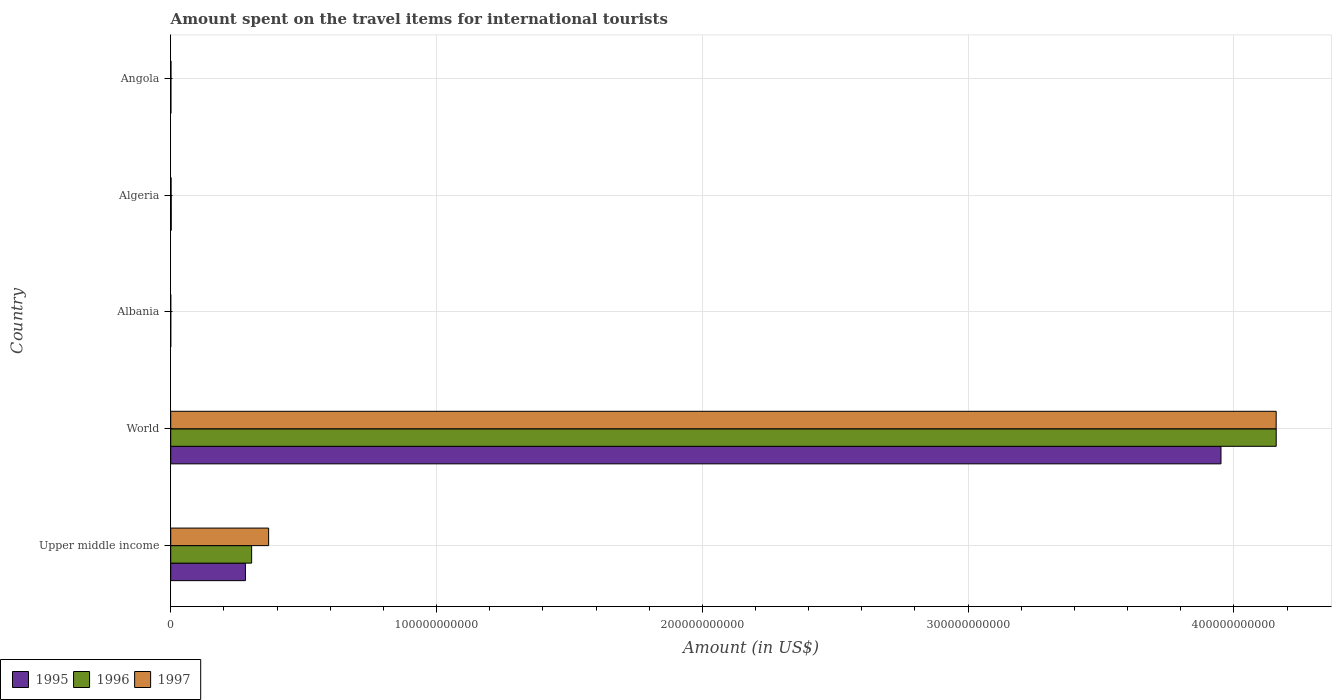Are the number of bars per tick equal to the number of legend labels?
Give a very brief answer. Yes. Are the number of bars on each tick of the Y-axis equal?
Your answer should be compact. Yes. How many bars are there on the 2nd tick from the bottom?
Make the answer very short. 3. What is the label of the 5th group of bars from the top?
Ensure brevity in your answer.  Upper middle income. In how many cases, is the number of bars for a given country not equal to the number of legend labels?
Provide a short and direct response. 0. What is the amount spent on the travel items for international tourists in 1995 in Albania?
Offer a terse response. 7.00e+06. Across all countries, what is the maximum amount spent on the travel items for international tourists in 1995?
Ensure brevity in your answer.  3.95e+11. In which country was the amount spent on the travel items for international tourists in 1995 maximum?
Your answer should be very brief. World. In which country was the amount spent on the travel items for international tourists in 1995 minimum?
Your response must be concise. Albania. What is the total amount spent on the travel items for international tourists in 1995 in the graph?
Make the answer very short. 4.24e+11. What is the difference between the amount spent on the travel items for international tourists in 1995 in Angola and that in Upper middle income?
Offer a terse response. -2.80e+1. What is the difference between the amount spent on the travel items for international tourists in 1996 in Albania and the amount spent on the travel items for international tourists in 1997 in Algeria?
Provide a succinct answer. -1.32e+08. What is the average amount spent on the travel items for international tourists in 1996 per country?
Provide a short and direct response. 8.93e+1. What is the difference between the amount spent on the travel items for international tourists in 1996 and amount spent on the travel items for international tourists in 1997 in Upper middle income?
Give a very brief answer. -6.39e+09. In how many countries, is the amount spent on the travel items for international tourists in 1997 greater than 80000000000 US$?
Ensure brevity in your answer.  1. What is the ratio of the amount spent on the travel items for international tourists in 1995 in Algeria to that in Upper middle income?
Provide a short and direct response. 0.01. Is the difference between the amount spent on the travel items for international tourists in 1996 in Albania and World greater than the difference between the amount spent on the travel items for international tourists in 1997 in Albania and World?
Offer a very short reply. No. What is the difference between the highest and the second highest amount spent on the travel items for international tourists in 1995?
Give a very brief answer. 3.67e+11. What is the difference between the highest and the lowest amount spent on the travel items for international tourists in 1995?
Offer a terse response. 3.95e+11. In how many countries, is the amount spent on the travel items for international tourists in 1997 greater than the average amount spent on the travel items for international tourists in 1997 taken over all countries?
Give a very brief answer. 1. Is the sum of the amount spent on the travel items for international tourists in 1996 in Albania and Algeria greater than the maximum amount spent on the travel items for international tourists in 1997 across all countries?
Your response must be concise. No. Is it the case that in every country, the sum of the amount spent on the travel items for international tourists in 1997 and amount spent on the travel items for international tourists in 1995 is greater than the amount spent on the travel items for international tourists in 1996?
Provide a short and direct response. No. Are all the bars in the graph horizontal?
Offer a terse response. Yes. What is the difference between two consecutive major ticks on the X-axis?
Provide a succinct answer. 1.00e+11. Does the graph contain any zero values?
Your response must be concise. No. How are the legend labels stacked?
Make the answer very short. Horizontal. What is the title of the graph?
Your response must be concise. Amount spent on the travel items for international tourists. What is the label or title of the X-axis?
Offer a terse response. Amount (in US$). What is the Amount (in US$) of 1995 in Upper middle income?
Your answer should be very brief. 2.81e+1. What is the Amount (in US$) of 1996 in Upper middle income?
Provide a succinct answer. 3.04e+1. What is the Amount (in US$) of 1997 in Upper middle income?
Your answer should be very brief. 3.68e+1. What is the Amount (in US$) in 1995 in World?
Give a very brief answer. 3.95e+11. What is the Amount (in US$) in 1996 in World?
Ensure brevity in your answer.  4.16e+11. What is the Amount (in US$) of 1997 in World?
Provide a succinct answer. 4.16e+11. What is the Amount (in US$) in 1995 in Albania?
Offer a very short reply. 7.00e+06. What is the Amount (in US$) of 1995 in Algeria?
Keep it short and to the point. 1.86e+08. What is the Amount (in US$) of 1996 in Algeria?
Your response must be concise. 1.88e+08. What is the Amount (in US$) of 1997 in Algeria?
Offer a terse response. 1.44e+08. What is the Amount (in US$) of 1995 in Angola?
Provide a succinct answer. 7.50e+07. What is the Amount (in US$) in 1996 in Angola?
Ensure brevity in your answer.  7.30e+07. What is the Amount (in US$) in 1997 in Angola?
Offer a terse response. 9.80e+07. Across all countries, what is the maximum Amount (in US$) in 1995?
Offer a terse response. 3.95e+11. Across all countries, what is the maximum Amount (in US$) in 1996?
Provide a succinct answer. 4.16e+11. Across all countries, what is the maximum Amount (in US$) of 1997?
Your answer should be compact. 4.16e+11. Across all countries, what is the minimum Amount (in US$) in 1995?
Keep it short and to the point. 7.00e+06. What is the total Amount (in US$) of 1995 in the graph?
Offer a terse response. 4.24e+11. What is the total Amount (in US$) in 1996 in the graph?
Your answer should be very brief. 4.47e+11. What is the total Amount (in US$) in 1997 in the graph?
Offer a terse response. 4.53e+11. What is the difference between the Amount (in US$) in 1995 in Upper middle income and that in World?
Your answer should be compact. -3.67e+11. What is the difference between the Amount (in US$) in 1996 in Upper middle income and that in World?
Give a very brief answer. -3.85e+11. What is the difference between the Amount (in US$) in 1997 in Upper middle income and that in World?
Provide a succinct answer. -3.79e+11. What is the difference between the Amount (in US$) in 1995 in Upper middle income and that in Albania?
Your answer should be very brief. 2.81e+1. What is the difference between the Amount (in US$) in 1996 in Upper middle income and that in Albania?
Give a very brief answer. 3.04e+1. What is the difference between the Amount (in US$) of 1997 in Upper middle income and that in Albania?
Your response must be concise. 3.68e+1. What is the difference between the Amount (in US$) in 1995 in Upper middle income and that in Algeria?
Provide a succinct answer. 2.79e+1. What is the difference between the Amount (in US$) of 1996 in Upper middle income and that in Algeria?
Provide a short and direct response. 3.03e+1. What is the difference between the Amount (in US$) in 1997 in Upper middle income and that in Algeria?
Give a very brief answer. 3.67e+1. What is the difference between the Amount (in US$) of 1995 in Upper middle income and that in Angola?
Your answer should be compact. 2.80e+1. What is the difference between the Amount (in US$) of 1996 in Upper middle income and that in Angola?
Your answer should be very brief. 3.04e+1. What is the difference between the Amount (in US$) of 1997 in Upper middle income and that in Angola?
Ensure brevity in your answer.  3.67e+1. What is the difference between the Amount (in US$) of 1995 in World and that in Albania?
Your response must be concise. 3.95e+11. What is the difference between the Amount (in US$) in 1996 in World and that in Albania?
Offer a very short reply. 4.16e+11. What is the difference between the Amount (in US$) of 1997 in World and that in Albania?
Provide a short and direct response. 4.16e+11. What is the difference between the Amount (in US$) in 1995 in World and that in Algeria?
Offer a terse response. 3.95e+11. What is the difference between the Amount (in US$) in 1996 in World and that in Algeria?
Your answer should be compact. 4.16e+11. What is the difference between the Amount (in US$) in 1997 in World and that in Algeria?
Give a very brief answer. 4.16e+11. What is the difference between the Amount (in US$) in 1995 in World and that in Angola?
Your answer should be very brief. 3.95e+11. What is the difference between the Amount (in US$) of 1996 in World and that in Angola?
Give a very brief answer. 4.16e+11. What is the difference between the Amount (in US$) of 1997 in World and that in Angola?
Your answer should be very brief. 4.16e+11. What is the difference between the Amount (in US$) of 1995 in Albania and that in Algeria?
Give a very brief answer. -1.79e+08. What is the difference between the Amount (in US$) in 1996 in Albania and that in Algeria?
Ensure brevity in your answer.  -1.76e+08. What is the difference between the Amount (in US$) of 1997 in Albania and that in Algeria?
Your answer should be compact. -1.39e+08. What is the difference between the Amount (in US$) in 1995 in Albania and that in Angola?
Offer a terse response. -6.80e+07. What is the difference between the Amount (in US$) in 1996 in Albania and that in Angola?
Provide a succinct answer. -6.10e+07. What is the difference between the Amount (in US$) of 1997 in Albania and that in Angola?
Your answer should be compact. -9.30e+07. What is the difference between the Amount (in US$) of 1995 in Algeria and that in Angola?
Your answer should be compact. 1.11e+08. What is the difference between the Amount (in US$) in 1996 in Algeria and that in Angola?
Your answer should be very brief. 1.15e+08. What is the difference between the Amount (in US$) of 1997 in Algeria and that in Angola?
Offer a terse response. 4.60e+07. What is the difference between the Amount (in US$) of 1995 in Upper middle income and the Amount (in US$) of 1996 in World?
Provide a succinct answer. -3.88e+11. What is the difference between the Amount (in US$) in 1995 in Upper middle income and the Amount (in US$) in 1997 in World?
Give a very brief answer. -3.88e+11. What is the difference between the Amount (in US$) in 1996 in Upper middle income and the Amount (in US$) in 1997 in World?
Your response must be concise. -3.85e+11. What is the difference between the Amount (in US$) of 1995 in Upper middle income and the Amount (in US$) of 1996 in Albania?
Your answer should be compact. 2.81e+1. What is the difference between the Amount (in US$) in 1995 in Upper middle income and the Amount (in US$) in 1997 in Albania?
Offer a very short reply. 2.81e+1. What is the difference between the Amount (in US$) in 1996 in Upper middle income and the Amount (in US$) in 1997 in Albania?
Offer a very short reply. 3.04e+1. What is the difference between the Amount (in US$) in 1995 in Upper middle income and the Amount (in US$) in 1996 in Algeria?
Make the answer very short. 2.79e+1. What is the difference between the Amount (in US$) of 1995 in Upper middle income and the Amount (in US$) of 1997 in Algeria?
Offer a very short reply. 2.80e+1. What is the difference between the Amount (in US$) of 1996 in Upper middle income and the Amount (in US$) of 1997 in Algeria?
Offer a terse response. 3.03e+1. What is the difference between the Amount (in US$) in 1995 in Upper middle income and the Amount (in US$) in 1996 in Angola?
Make the answer very short. 2.80e+1. What is the difference between the Amount (in US$) in 1995 in Upper middle income and the Amount (in US$) in 1997 in Angola?
Offer a terse response. 2.80e+1. What is the difference between the Amount (in US$) in 1996 in Upper middle income and the Amount (in US$) in 1997 in Angola?
Your response must be concise. 3.03e+1. What is the difference between the Amount (in US$) of 1995 in World and the Amount (in US$) of 1996 in Albania?
Offer a terse response. 3.95e+11. What is the difference between the Amount (in US$) in 1995 in World and the Amount (in US$) in 1997 in Albania?
Your response must be concise. 3.95e+11. What is the difference between the Amount (in US$) in 1996 in World and the Amount (in US$) in 1997 in Albania?
Keep it short and to the point. 4.16e+11. What is the difference between the Amount (in US$) in 1995 in World and the Amount (in US$) in 1996 in Algeria?
Keep it short and to the point. 3.95e+11. What is the difference between the Amount (in US$) of 1995 in World and the Amount (in US$) of 1997 in Algeria?
Your answer should be compact. 3.95e+11. What is the difference between the Amount (in US$) of 1996 in World and the Amount (in US$) of 1997 in Algeria?
Provide a short and direct response. 4.16e+11. What is the difference between the Amount (in US$) of 1995 in World and the Amount (in US$) of 1996 in Angola?
Offer a terse response. 3.95e+11. What is the difference between the Amount (in US$) of 1995 in World and the Amount (in US$) of 1997 in Angola?
Your answer should be very brief. 3.95e+11. What is the difference between the Amount (in US$) in 1996 in World and the Amount (in US$) in 1997 in Angola?
Keep it short and to the point. 4.16e+11. What is the difference between the Amount (in US$) of 1995 in Albania and the Amount (in US$) of 1996 in Algeria?
Give a very brief answer. -1.81e+08. What is the difference between the Amount (in US$) of 1995 in Albania and the Amount (in US$) of 1997 in Algeria?
Your response must be concise. -1.37e+08. What is the difference between the Amount (in US$) in 1996 in Albania and the Amount (in US$) in 1997 in Algeria?
Ensure brevity in your answer.  -1.32e+08. What is the difference between the Amount (in US$) in 1995 in Albania and the Amount (in US$) in 1996 in Angola?
Ensure brevity in your answer.  -6.60e+07. What is the difference between the Amount (in US$) of 1995 in Albania and the Amount (in US$) of 1997 in Angola?
Provide a short and direct response. -9.10e+07. What is the difference between the Amount (in US$) in 1996 in Albania and the Amount (in US$) in 1997 in Angola?
Provide a succinct answer. -8.60e+07. What is the difference between the Amount (in US$) in 1995 in Algeria and the Amount (in US$) in 1996 in Angola?
Keep it short and to the point. 1.13e+08. What is the difference between the Amount (in US$) in 1995 in Algeria and the Amount (in US$) in 1997 in Angola?
Your response must be concise. 8.80e+07. What is the difference between the Amount (in US$) of 1996 in Algeria and the Amount (in US$) of 1997 in Angola?
Your answer should be compact. 9.00e+07. What is the average Amount (in US$) in 1995 per country?
Offer a very short reply. 8.47e+1. What is the average Amount (in US$) of 1996 per country?
Your response must be concise. 8.93e+1. What is the average Amount (in US$) of 1997 per country?
Offer a very short reply. 9.06e+1. What is the difference between the Amount (in US$) of 1995 and Amount (in US$) of 1996 in Upper middle income?
Your response must be concise. -2.34e+09. What is the difference between the Amount (in US$) of 1995 and Amount (in US$) of 1997 in Upper middle income?
Your response must be concise. -8.72e+09. What is the difference between the Amount (in US$) in 1996 and Amount (in US$) in 1997 in Upper middle income?
Provide a short and direct response. -6.39e+09. What is the difference between the Amount (in US$) of 1995 and Amount (in US$) of 1996 in World?
Your answer should be very brief. -2.08e+1. What is the difference between the Amount (in US$) of 1995 and Amount (in US$) of 1997 in World?
Make the answer very short. -2.08e+1. What is the difference between the Amount (in US$) of 1996 and Amount (in US$) of 1997 in World?
Offer a terse response. 1.91e+07. What is the difference between the Amount (in US$) in 1995 and Amount (in US$) in 1996 in Albania?
Your answer should be compact. -5.00e+06. What is the difference between the Amount (in US$) in 1995 and Amount (in US$) in 1997 in Algeria?
Your answer should be very brief. 4.20e+07. What is the difference between the Amount (in US$) in 1996 and Amount (in US$) in 1997 in Algeria?
Your answer should be compact. 4.40e+07. What is the difference between the Amount (in US$) of 1995 and Amount (in US$) of 1997 in Angola?
Keep it short and to the point. -2.30e+07. What is the difference between the Amount (in US$) of 1996 and Amount (in US$) of 1997 in Angola?
Ensure brevity in your answer.  -2.50e+07. What is the ratio of the Amount (in US$) in 1995 in Upper middle income to that in World?
Give a very brief answer. 0.07. What is the ratio of the Amount (in US$) in 1996 in Upper middle income to that in World?
Provide a short and direct response. 0.07. What is the ratio of the Amount (in US$) of 1997 in Upper middle income to that in World?
Your answer should be very brief. 0.09. What is the ratio of the Amount (in US$) of 1995 in Upper middle income to that in Albania?
Your response must be concise. 4015.88. What is the ratio of the Amount (in US$) of 1996 in Upper middle income to that in Albania?
Your answer should be compact. 2537.19. What is the ratio of the Amount (in US$) in 1997 in Upper middle income to that in Albania?
Offer a very short reply. 7367.01. What is the ratio of the Amount (in US$) in 1995 in Upper middle income to that in Algeria?
Your answer should be very brief. 151.14. What is the ratio of the Amount (in US$) of 1996 in Upper middle income to that in Algeria?
Keep it short and to the point. 161.95. What is the ratio of the Amount (in US$) in 1997 in Upper middle income to that in Algeria?
Offer a terse response. 255.8. What is the ratio of the Amount (in US$) in 1995 in Upper middle income to that in Angola?
Your response must be concise. 374.82. What is the ratio of the Amount (in US$) in 1996 in Upper middle income to that in Angola?
Give a very brief answer. 417.07. What is the ratio of the Amount (in US$) of 1997 in Upper middle income to that in Angola?
Your response must be concise. 375.87. What is the ratio of the Amount (in US$) in 1995 in World to that in Albania?
Provide a succinct answer. 5.64e+04. What is the ratio of the Amount (in US$) of 1996 in World to that in Albania?
Offer a very short reply. 3.47e+04. What is the ratio of the Amount (in US$) of 1997 in World to that in Albania?
Your response must be concise. 8.32e+04. What is the ratio of the Amount (in US$) of 1995 in World to that in Algeria?
Your answer should be very brief. 2124.35. What is the ratio of the Amount (in US$) in 1996 in World to that in Algeria?
Offer a terse response. 2212.28. What is the ratio of the Amount (in US$) of 1997 in World to that in Algeria?
Your response must be concise. 2888.12. What is the ratio of the Amount (in US$) of 1995 in World to that in Angola?
Your answer should be compact. 5268.38. What is the ratio of the Amount (in US$) of 1996 in World to that in Angola?
Keep it short and to the point. 5697.38. What is the ratio of the Amount (in US$) in 1997 in World to that in Angola?
Provide a succinct answer. 4243.77. What is the ratio of the Amount (in US$) in 1995 in Albania to that in Algeria?
Provide a succinct answer. 0.04. What is the ratio of the Amount (in US$) in 1996 in Albania to that in Algeria?
Offer a terse response. 0.06. What is the ratio of the Amount (in US$) in 1997 in Albania to that in Algeria?
Offer a very short reply. 0.03. What is the ratio of the Amount (in US$) in 1995 in Albania to that in Angola?
Ensure brevity in your answer.  0.09. What is the ratio of the Amount (in US$) of 1996 in Albania to that in Angola?
Ensure brevity in your answer.  0.16. What is the ratio of the Amount (in US$) of 1997 in Albania to that in Angola?
Your response must be concise. 0.05. What is the ratio of the Amount (in US$) of 1995 in Algeria to that in Angola?
Provide a short and direct response. 2.48. What is the ratio of the Amount (in US$) of 1996 in Algeria to that in Angola?
Your answer should be compact. 2.58. What is the ratio of the Amount (in US$) of 1997 in Algeria to that in Angola?
Your answer should be compact. 1.47. What is the difference between the highest and the second highest Amount (in US$) in 1995?
Your answer should be compact. 3.67e+11. What is the difference between the highest and the second highest Amount (in US$) of 1996?
Give a very brief answer. 3.85e+11. What is the difference between the highest and the second highest Amount (in US$) in 1997?
Offer a very short reply. 3.79e+11. What is the difference between the highest and the lowest Amount (in US$) in 1995?
Ensure brevity in your answer.  3.95e+11. What is the difference between the highest and the lowest Amount (in US$) of 1996?
Your answer should be compact. 4.16e+11. What is the difference between the highest and the lowest Amount (in US$) in 1997?
Your answer should be compact. 4.16e+11. 